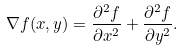Convert formula to latex. <formula><loc_0><loc_0><loc_500><loc_500>\nabla f ( x , y ) = \frac { \partial ^ { 2 } f } { \partial x ^ { 2 } } + \frac { \partial ^ { 2 } f } { \partial y ^ { 2 } } .</formula> 